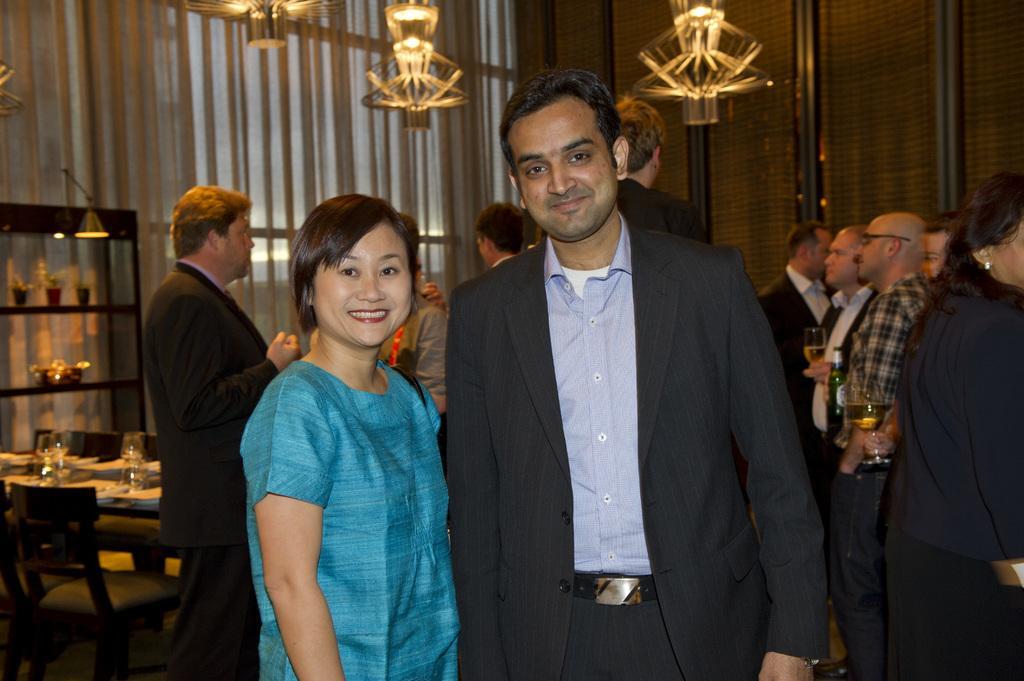Could you give a brief overview of what you see in this image? Here is a women and men standing and smiling. At background there are group of people standing and holding wine glasses. This is a table with some things on it. This is a empty chair. At background I can see a rack with some small flower pots. 